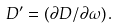Convert formula to latex. <formula><loc_0><loc_0><loc_500><loc_500>D ^ { \prime } = ( \partial D / \partial \omega ) \, .</formula> 